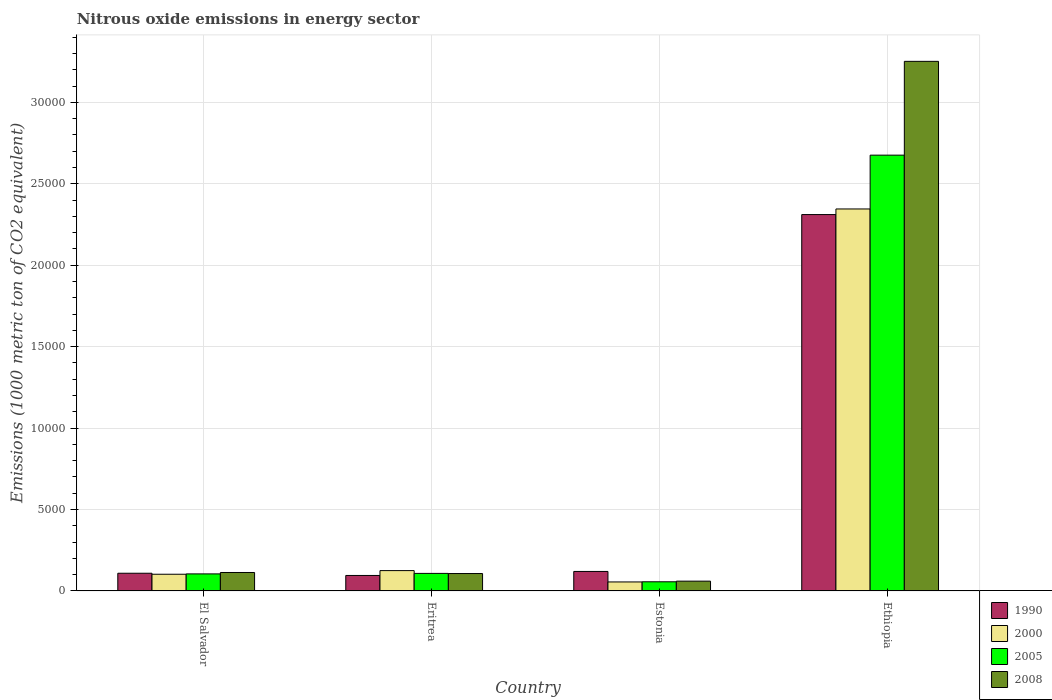How many groups of bars are there?
Make the answer very short. 4. How many bars are there on the 3rd tick from the left?
Give a very brief answer. 4. What is the label of the 3rd group of bars from the left?
Offer a terse response. Estonia. What is the amount of nitrous oxide emitted in 2005 in Estonia?
Provide a succinct answer. 563.9. Across all countries, what is the maximum amount of nitrous oxide emitted in 1990?
Make the answer very short. 2.31e+04. Across all countries, what is the minimum amount of nitrous oxide emitted in 2000?
Provide a short and direct response. 554.4. In which country was the amount of nitrous oxide emitted in 2000 maximum?
Ensure brevity in your answer.  Ethiopia. In which country was the amount of nitrous oxide emitted in 1990 minimum?
Make the answer very short. Eritrea. What is the total amount of nitrous oxide emitted in 1990 in the graph?
Offer a very short reply. 2.64e+04. What is the difference between the amount of nitrous oxide emitted in 2005 in Eritrea and that in Estonia?
Your answer should be very brief. 515.4. What is the difference between the amount of nitrous oxide emitted in 1990 in Eritrea and the amount of nitrous oxide emitted in 2008 in Estonia?
Your response must be concise. 349. What is the average amount of nitrous oxide emitted in 2005 per country?
Your answer should be very brief. 7363.52. What is the difference between the amount of nitrous oxide emitted of/in 2000 and amount of nitrous oxide emitted of/in 1990 in El Salvador?
Give a very brief answer. -60.8. What is the ratio of the amount of nitrous oxide emitted in 1990 in Eritrea to that in Ethiopia?
Provide a short and direct response. 0.04. What is the difference between the highest and the second highest amount of nitrous oxide emitted in 2005?
Ensure brevity in your answer.  2.57e+04. What is the difference between the highest and the lowest amount of nitrous oxide emitted in 2008?
Your answer should be very brief. 3.19e+04. Is it the case that in every country, the sum of the amount of nitrous oxide emitted in 2000 and amount of nitrous oxide emitted in 2005 is greater than the sum of amount of nitrous oxide emitted in 2008 and amount of nitrous oxide emitted in 1990?
Ensure brevity in your answer.  No. What does the 2nd bar from the left in Ethiopia represents?
Provide a short and direct response. 2000. What does the 4th bar from the right in Estonia represents?
Keep it short and to the point. 1990. Is it the case that in every country, the sum of the amount of nitrous oxide emitted in 2000 and amount of nitrous oxide emitted in 2008 is greater than the amount of nitrous oxide emitted in 1990?
Keep it short and to the point. No. How many bars are there?
Your answer should be compact. 16. How many countries are there in the graph?
Your answer should be compact. 4. Does the graph contain any zero values?
Your answer should be very brief. No. Does the graph contain grids?
Keep it short and to the point. Yes. How many legend labels are there?
Make the answer very short. 4. How are the legend labels stacked?
Provide a short and direct response. Vertical. What is the title of the graph?
Your answer should be compact. Nitrous oxide emissions in energy sector. What is the label or title of the Y-axis?
Give a very brief answer. Emissions (1000 metric ton of CO2 equivalent). What is the Emissions (1000 metric ton of CO2 equivalent) of 1990 in El Salvador?
Make the answer very short. 1088.8. What is the Emissions (1000 metric ton of CO2 equivalent) of 2000 in El Salvador?
Your answer should be very brief. 1028. What is the Emissions (1000 metric ton of CO2 equivalent) of 2005 in El Salvador?
Provide a short and direct response. 1049.1. What is the Emissions (1000 metric ton of CO2 equivalent) of 2008 in El Salvador?
Your answer should be compact. 1135. What is the Emissions (1000 metric ton of CO2 equivalent) of 1990 in Eritrea?
Your response must be concise. 953. What is the Emissions (1000 metric ton of CO2 equivalent) in 2000 in Eritrea?
Your answer should be very brief. 1251.3. What is the Emissions (1000 metric ton of CO2 equivalent) in 2005 in Eritrea?
Your answer should be compact. 1079.3. What is the Emissions (1000 metric ton of CO2 equivalent) of 2008 in Eritrea?
Provide a short and direct response. 1070.9. What is the Emissions (1000 metric ton of CO2 equivalent) in 1990 in Estonia?
Your answer should be very brief. 1199.7. What is the Emissions (1000 metric ton of CO2 equivalent) of 2000 in Estonia?
Offer a terse response. 554.4. What is the Emissions (1000 metric ton of CO2 equivalent) of 2005 in Estonia?
Offer a very short reply. 563.9. What is the Emissions (1000 metric ton of CO2 equivalent) of 2008 in Estonia?
Ensure brevity in your answer.  604. What is the Emissions (1000 metric ton of CO2 equivalent) of 1990 in Ethiopia?
Provide a succinct answer. 2.31e+04. What is the Emissions (1000 metric ton of CO2 equivalent) of 2000 in Ethiopia?
Ensure brevity in your answer.  2.35e+04. What is the Emissions (1000 metric ton of CO2 equivalent) of 2005 in Ethiopia?
Provide a short and direct response. 2.68e+04. What is the Emissions (1000 metric ton of CO2 equivalent) of 2008 in Ethiopia?
Provide a succinct answer. 3.25e+04. Across all countries, what is the maximum Emissions (1000 metric ton of CO2 equivalent) in 1990?
Give a very brief answer. 2.31e+04. Across all countries, what is the maximum Emissions (1000 metric ton of CO2 equivalent) in 2000?
Your response must be concise. 2.35e+04. Across all countries, what is the maximum Emissions (1000 metric ton of CO2 equivalent) in 2005?
Ensure brevity in your answer.  2.68e+04. Across all countries, what is the maximum Emissions (1000 metric ton of CO2 equivalent) in 2008?
Your answer should be compact. 3.25e+04. Across all countries, what is the minimum Emissions (1000 metric ton of CO2 equivalent) of 1990?
Make the answer very short. 953. Across all countries, what is the minimum Emissions (1000 metric ton of CO2 equivalent) of 2000?
Ensure brevity in your answer.  554.4. Across all countries, what is the minimum Emissions (1000 metric ton of CO2 equivalent) in 2005?
Give a very brief answer. 563.9. Across all countries, what is the minimum Emissions (1000 metric ton of CO2 equivalent) of 2008?
Your response must be concise. 604. What is the total Emissions (1000 metric ton of CO2 equivalent) in 1990 in the graph?
Your response must be concise. 2.64e+04. What is the total Emissions (1000 metric ton of CO2 equivalent) in 2000 in the graph?
Ensure brevity in your answer.  2.63e+04. What is the total Emissions (1000 metric ton of CO2 equivalent) in 2005 in the graph?
Give a very brief answer. 2.95e+04. What is the total Emissions (1000 metric ton of CO2 equivalent) of 2008 in the graph?
Ensure brevity in your answer.  3.53e+04. What is the difference between the Emissions (1000 metric ton of CO2 equivalent) of 1990 in El Salvador and that in Eritrea?
Offer a terse response. 135.8. What is the difference between the Emissions (1000 metric ton of CO2 equivalent) in 2000 in El Salvador and that in Eritrea?
Offer a very short reply. -223.3. What is the difference between the Emissions (1000 metric ton of CO2 equivalent) in 2005 in El Salvador and that in Eritrea?
Your answer should be very brief. -30.2. What is the difference between the Emissions (1000 metric ton of CO2 equivalent) in 2008 in El Salvador and that in Eritrea?
Give a very brief answer. 64.1. What is the difference between the Emissions (1000 metric ton of CO2 equivalent) of 1990 in El Salvador and that in Estonia?
Your answer should be compact. -110.9. What is the difference between the Emissions (1000 metric ton of CO2 equivalent) in 2000 in El Salvador and that in Estonia?
Ensure brevity in your answer.  473.6. What is the difference between the Emissions (1000 metric ton of CO2 equivalent) in 2005 in El Salvador and that in Estonia?
Keep it short and to the point. 485.2. What is the difference between the Emissions (1000 metric ton of CO2 equivalent) in 2008 in El Salvador and that in Estonia?
Keep it short and to the point. 531. What is the difference between the Emissions (1000 metric ton of CO2 equivalent) of 1990 in El Salvador and that in Ethiopia?
Your response must be concise. -2.20e+04. What is the difference between the Emissions (1000 metric ton of CO2 equivalent) in 2000 in El Salvador and that in Ethiopia?
Keep it short and to the point. -2.24e+04. What is the difference between the Emissions (1000 metric ton of CO2 equivalent) of 2005 in El Salvador and that in Ethiopia?
Make the answer very short. -2.57e+04. What is the difference between the Emissions (1000 metric ton of CO2 equivalent) in 2008 in El Salvador and that in Ethiopia?
Your answer should be very brief. -3.14e+04. What is the difference between the Emissions (1000 metric ton of CO2 equivalent) in 1990 in Eritrea and that in Estonia?
Ensure brevity in your answer.  -246.7. What is the difference between the Emissions (1000 metric ton of CO2 equivalent) of 2000 in Eritrea and that in Estonia?
Your response must be concise. 696.9. What is the difference between the Emissions (1000 metric ton of CO2 equivalent) in 2005 in Eritrea and that in Estonia?
Provide a short and direct response. 515.4. What is the difference between the Emissions (1000 metric ton of CO2 equivalent) of 2008 in Eritrea and that in Estonia?
Offer a terse response. 466.9. What is the difference between the Emissions (1000 metric ton of CO2 equivalent) of 1990 in Eritrea and that in Ethiopia?
Keep it short and to the point. -2.22e+04. What is the difference between the Emissions (1000 metric ton of CO2 equivalent) in 2000 in Eritrea and that in Ethiopia?
Provide a succinct answer. -2.22e+04. What is the difference between the Emissions (1000 metric ton of CO2 equivalent) in 2005 in Eritrea and that in Ethiopia?
Ensure brevity in your answer.  -2.57e+04. What is the difference between the Emissions (1000 metric ton of CO2 equivalent) of 2008 in Eritrea and that in Ethiopia?
Your answer should be compact. -3.15e+04. What is the difference between the Emissions (1000 metric ton of CO2 equivalent) of 1990 in Estonia and that in Ethiopia?
Offer a very short reply. -2.19e+04. What is the difference between the Emissions (1000 metric ton of CO2 equivalent) in 2000 in Estonia and that in Ethiopia?
Make the answer very short. -2.29e+04. What is the difference between the Emissions (1000 metric ton of CO2 equivalent) in 2005 in Estonia and that in Ethiopia?
Ensure brevity in your answer.  -2.62e+04. What is the difference between the Emissions (1000 metric ton of CO2 equivalent) of 2008 in Estonia and that in Ethiopia?
Provide a succinct answer. -3.19e+04. What is the difference between the Emissions (1000 metric ton of CO2 equivalent) in 1990 in El Salvador and the Emissions (1000 metric ton of CO2 equivalent) in 2000 in Eritrea?
Give a very brief answer. -162.5. What is the difference between the Emissions (1000 metric ton of CO2 equivalent) of 2000 in El Salvador and the Emissions (1000 metric ton of CO2 equivalent) of 2005 in Eritrea?
Offer a very short reply. -51.3. What is the difference between the Emissions (1000 metric ton of CO2 equivalent) of 2000 in El Salvador and the Emissions (1000 metric ton of CO2 equivalent) of 2008 in Eritrea?
Give a very brief answer. -42.9. What is the difference between the Emissions (1000 metric ton of CO2 equivalent) of 2005 in El Salvador and the Emissions (1000 metric ton of CO2 equivalent) of 2008 in Eritrea?
Keep it short and to the point. -21.8. What is the difference between the Emissions (1000 metric ton of CO2 equivalent) of 1990 in El Salvador and the Emissions (1000 metric ton of CO2 equivalent) of 2000 in Estonia?
Give a very brief answer. 534.4. What is the difference between the Emissions (1000 metric ton of CO2 equivalent) of 1990 in El Salvador and the Emissions (1000 metric ton of CO2 equivalent) of 2005 in Estonia?
Your answer should be very brief. 524.9. What is the difference between the Emissions (1000 metric ton of CO2 equivalent) of 1990 in El Salvador and the Emissions (1000 metric ton of CO2 equivalent) of 2008 in Estonia?
Give a very brief answer. 484.8. What is the difference between the Emissions (1000 metric ton of CO2 equivalent) of 2000 in El Salvador and the Emissions (1000 metric ton of CO2 equivalent) of 2005 in Estonia?
Provide a short and direct response. 464.1. What is the difference between the Emissions (1000 metric ton of CO2 equivalent) in 2000 in El Salvador and the Emissions (1000 metric ton of CO2 equivalent) in 2008 in Estonia?
Make the answer very short. 424. What is the difference between the Emissions (1000 metric ton of CO2 equivalent) of 2005 in El Salvador and the Emissions (1000 metric ton of CO2 equivalent) of 2008 in Estonia?
Offer a terse response. 445.1. What is the difference between the Emissions (1000 metric ton of CO2 equivalent) of 1990 in El Salvador and the Emissions (1000 metric ton of CO2 equivalent) of 2000 in Ethiopia?
Provide a short and direct response. -2.24e+04. What is the difference between the Emissions (1000 metric ton of CO2 equivalent) of 1990 in El Salvador and the Emissions (1000 metric ton of CO2 equivalent) of 2005 in Ethiopia?
Ensure brevity in your answer.  -2.57e+04. What is the difference between the Emissions (1000 metric ton of CO2 equivalent) in 1990 in El Salvador and the Emissions (1000 metric ton of CO2 equivalent) in 2008 in Ethiopia?
Offer a very short reply. -3.14e+04. What is the difference between the Emissions (1000 metric ton of CO2 equivalent) of 2000 in El Salvador and the Emissions (1000 metric ton of CO2 equivalent) of 2005 in Ethiopia?
Keep it short and to the point. -2.57e+04. What is the difference between the Emissions (1000 metric ton of CO2 equivalent) of 2000 in El Salvador and the Emissions (1000 metric ton of CO2 equivalent) of 2008 in Ethiopia?
Keep it short and to the point. -3.15e+04. What is the difference between the Emissions (1000 metric ton of CO2 equivalent) of 2005 in El Salvador and the Emissions (1000 metric ton of CO2 equivalent) of 2008 in Ethiopia?
Provide a short and direct response. -3.15e+04. What is the difference between the Emissions (1000 metric ton of CO2 equivalent) of 1990 in Eritrea and the Emissions (1000 metric ton of CO2 equivalent) of 2000 in Estonia?
Your answer should be compact. 398.6. What is the difference between the Emissions (1000 metric ton of CO2 equivalent) in 1990 in Eritrea and the Emissions (1000 metric ton of CO2 equivalent) in 2005 in Estonia?
Keep it short and to the point. 389.1. What is the difference between the Emissions (1000 metric ton of CO2 equivalent) of 1990 in Eritrea and the Emissions (1000 metric ton of CO2 equivalent) of 2008 in Estonia?
Give a very brief answer. 349. What is the difference between the Emissions (1000 metric ton of CO2 equivalent) of 2000 in Eritrea and the Emissions (1000 metric ton of CO2 equivalent) of 2005 in Estonia?
Keep it short and to the point. 687.4. What is the difference between the Emissions (1000 metric ton of CO2 equivalent) in 2000 in Eritrea and the Emissions (1000 metric ton of CO2 equivalent) in 2008 in Estonia?
Offer a very short reply. 647.3. What is the difference between the Emissions (1000 metric ton of CO2 equivalent) in 2005 in Eritrea and the Emissions (1000 metric ton of CO2 equivalent) in 2008 in Estonia?
Give a very brief answer. 475.3. What is the difference between the Emissions (1000 metric ton of CO2 equivalent) in 1990 in Eritrea and the Emissions (1000 metric ton of CO2 equivalent) in 2000 in Ethiopia?
Your answer should be very brief. -2.25e+04. What is the difference between the Emissions (1000 metric ton of CO2 equivalent) of 1990 in Eritrea and the Emissions (1000 metric ton of CO2 equivalent) of 2005 in Ethiopia?
Ensure brevity in your answer.  -2.58e+04. What is the difference between the Emissions (1000 metric ton of CO2 equivalent) of 1990 in Eritrea and the Emissions (1000 metric ton of CO2 equivalent) of 2008 in Ethiopia?
Your answer should be compact. -3.16e+04. What is the difference between the Emissions (1000 metric ton of CO2 equivalent) in 2000 in Eritrea and the Emissions (1000 metric ton of CO2 equivalent) in 2005 in Ethiopia?
Keep it short and to the point. -2.55e+04. What is the difference between the Emissions (1000 metric ton of CO2 equivalent) in 2000 in Eritrea and the Emissions (1000 metric ton of CO2 equivalent) in 2008 in Ethiopia?
Provide a succinct answer. -3.13e+04. What is the difference between the Emissions (1000 metric ton of CO2 equivalent) of 2005 in Eritrea and the Emissions (1000 metric ton of CO2 equivalent) of 2008 in Ethiopia?
Ensure brevity in your answer.  -3.14e+04. What is the difference between the Emissions (1000 metric ton of CO2 equivalent) of 1990 in Estonia and the Emissions (1000 metric ton of CO2 equivalent) of 2000 in Ethiopia?
Give a very brief answer. -2.23e+04. What is the difference between the Emissions (1000 metric ton of CO2 equivalent) in 1990 in Estonia and the Emissions (1000 metric ton of CO2 equivalent) in 2005 in Ethiopia?
Your answer should be very brief. -2.56e+04. What is the difference between the Emissions (1000 metric ton of CO2 equivalent) in 1990 in Estonia and the Emissions (1000 metric ton of CO2 equivalent) in 2008 in Ethiopia?
Your answer should be compact. -3.13e+04. What is the difference between the Emissions (1000 metric ton of CO2 equivalent) in 2000 in Estonia and the Emissions (1000 metric ton of CO2 equivalent) in 2005 in Ethiopia?
Your answer should be very brief. -2.62e+04. What is the difference between the Emissions (1000 metric ton of CO2 equivalent) in 2000 in Estonia and the Emissions (1000 metric ton of CO2 equivalent) in 2008 in Ethiopia?
Your answer should be compact. -3.20e+04. What is the difference between the Emissions (1000 metric ton of CO2 equivalent) of 2005 in Estonia and the Emissions (1000 metric ton of CO2 equivalent) of 2008 in Ethiopia?
Give a very brief answer. -3.20e+04. What is the average Emissions (1000 metric ton of CO2 equivalent) of 1990 per country?
Give a very brief answer. 6588.68. What is the average Emissions (1000 metric ton of CO2 equivalent) in 2000 per country?
Your answer should be compact. 6572.85. What is the average Emissions (1000 metric ton of CO2 equivalent) of 2005 per country?
Your answer should be very brief. 7363.52. What is the average Emissions (1000 metric ton of CO2 equivalent) of 2008 per country?
Your response must be concise. 8832.75. What is the difference between the Emissions (1000 metric ton of CO2 equivalent) in 1990 and Emissions (1000 metric ton of CO2 equivalent) in 2000 in El Salvador?
Keep it short and to the point. 60.8. What is the difference between the Emissions (1000 metric ton of CO2 equivalent) of 1990 and Emissions (1000 metric ton of CO2 equivalent) of 2005 in El Salvador?
Your response must be concise. 39.7. What is the difference between the Emissions (1000 metric ton of CO2 equivalent) in 1990 and Emissions (1000 metric ton of CO2 equivalent) in 2008 in El Salvador?
Provide a succinct answer. -46.2. What is the difference between the Emissions (1000 metric ton of CO2 equivalent) in 2000 and Emissions (1000 metric ton of CO2 equivalent) in 2005 in El Salvador?
Give a very brief answer. -21.1. What is the difference between the Emissions (1000 metric ton of CO2 equivalent) of 2000 and Emissions (1000 metric ton of CO2 equivalent) of 2008 in El Salvador?
Provide a succinct answer. -107. What is the difference between the Emissions (1000 metric ton of CO2 equivalent) of 2005 and Emissions (1000 metric ton of CO2 equivalent) of 2008 in El Salvador?
Your answer should be very brief. -85.9. What is the difference between the Emissions (1000 metric ton of CO2 equivalent) of 1990 and Emissions (1000 metric ton of CO2 equivalent) of 2000 in Eritrea?
Make the answer very short. -298.3. What is the difference between the Emissions (1000 metric ton of CO2 equivalent) in 1990 and Emissions (1000 metric ton of CO2 equivalent) in 2005 in Eritrea?
Provide a succinct answer. -126.3. What is the difference between the Emissions (1000 metric ton of CO2 equivalent) in 1990 and Emissions (1000 metric ton of CO2 equivalent) in 2008 in Eritrea?
Give a very brief answer. -117.9. What is the difference between the Emissions (1000 metric ton of CO2 equivalent) in 2000 and Emissions (1000 metric ton of CO2 equivalent) in 2005 in Eritrea?
Offer a terse response. 172. What is the difference between the Emissions (1000 metric ton of CO2 equivalent) in 2000 and Emissions (1000 metric ton of CO2 equivalent) in 2008 in Eritrea?
Offer a terse response. 180.4. What is the difference between the Emissions (1000 metric ton of CO2 equivalent) of 1990 and Emissions (1000 metric ton of CO2 equivalent) of 2000 in Estonia?
Your response must be concise. 645.3. What is the difference between the Emissions (1000 metric ton of CO2 equivalent) in 1990 and Emissions (1000 metric ton of CO2 equivalent) in 2005 in Estonia?
Offer a terse response. 635.8. What is the difference between the Emissions (1000 metric ton of CO2 equivalent) of 1990 and Emissions (1000 metric ton of CO2 equivalent) of 2008 in Estonia?
Provide a short and direct response. 595.7. What is the difference between the Emissions (1000 metric ton of CO2 equivalent) of 2000 and Emissions (1000 metric ton of CO2 equivalent) of 2005 in Estonia?
Your answer should be compact. -9.5. What is the difference between the Emissions (1000 metric ton of CO2 equivalent) of 2000 and Emissions (1000 metric ton of CO2 equivalent) of 2008 in Estonia?
Offer a terse response. -49.6. What is the difference between the Emissions (1000 metric ton of CO2 equivalent) of 2005 and Emissions (1000 metric ton of CO2 equivalent) of 2008 in Estonia?
Your response must be concise. -40.1. What is the difference between the Emissions (1000 metric ton of CO2 equivalent) in 1990 and Emissions (1000 metric ton of CO2 equivalent) in 2000 in Ethiopia?
Your response must be concise. -344.5. What is the difference between the Emissions (1000 metric ton of CO2 equivalent) of 1990 and Emissions (1000 metric ton of CO2 equivalent) of 2005 in Ethiopia?
Keep it short and to the point. -3648.6. What is the difference between the Emissions (1000 metric ton of CO2 equivalent) of 1990 and Emissions (1000 metric ton of CO2 equivalent) of 2008 in Ethiopia?
Your response must be concise. -9407.9. What is the difference between the Emissions (1000 metric ton of CO2 equivalent) of 2000 and Emissions (1000 metric ton of CO2 equivalent) of 2005 in Ethiopia?
Keep it short and to the point. -3304.1. What is the difference between the Emissions (1000 metric ton of CO2 equivalent) in 2000 and Emissions (1000 metric ton of CO2 equivalent) in 2008 in Ethiopia?
Your response must be concise. -9063.4. What is the difference between the Emissions (1000 metric ton of CO2 equivalent) of 2005 and Emissions (1000 metric ton of CO2 equivalent) of 2008 in Ethiopia?
Your answer should be very brief. -5759.3. What is the ratio of the Emissions (1000 metric ton of CO2 equivalent) of 1990 in El Salvador to that in Eritrea?
Ensure brevity in your answer.  1.14. What is the ratio of the Emissions (1000 metric ton of CO2 equivalent) in 2000 in El Salvador to that in Eritrea?
Make the answer very short. 0.82. What is the ratio of the Emissions (1000 metric ton of CO2 equivalent) of 2008 in El Salvador to that in Eritrea?
Provide a short and direct response. 1.06. What is the ratio of the Emissions (1000 metric ton of CO2 equivalent) of 1990 in El Salvador to that in Estonia?
Your response must be concise. 0.91. What is the ratio of the Emissions (1000 metric ton of CO2 equivalent) in 2000 in El Salvador to that in Estonia?
Offer a very short reply. 1.85. What is the ratio of the Emissions (1000 metric ton of CO2 equivalent) of 2005 in El Salvador to that in Estonia?
Give a very brief answer. 1.86. What is the ratio of the Emissions (1000 metric ton of CO2 equivalent) of 2008 in El Salvador to that in Estonia?
Your response must be concise. 1.88. What is the ratio of the Emissions (1000 metric ton of CO2 equivalent) of 1990 in El Salvador to that in Ethiopia?
Ensure brevity in your answer.  0.05. What is the ratio of the Emissions (1000 metric ton of CO2 equivalent) in 2000 in El Salvador to that in Ethiopia?
Your answer should be compact. 0.04. What is the ratio of the Emissions (1000 metric ton of CO2 equivalent) in 2005 in El Salvador to that in Ethiopia?
Make the answer very short. 0.04. What is the ratio of the Emissions (1000 metric ton of CO2 equivalent) in 2008 in El Salvador to that in Ethiopia?
Your answer should be compact. 0.03. What is the ratio of the Emissions (1000 metric ton of CO2 equivalent) in 1990 in Eritrea to that in Estonia?
Provide a succinct answer. 0.79. What is the ratio of the Emissions (1000 metric ton of CO2 equivalent) in 2000 in Eritrea to that in Estonia?
Make the answer very short. 2.26. What is the ratio of the Emissions (1000 metric ton of CO2 equivalent) of 2005 in Eritrea to that in Estonia?
Offer a terse response. 1.91. What is the ratio of the Emissions (1000 metric ton of CO2 equivalent) in 2008 in Eritrea to that in Estonia?
Offer a very short reply. 1.77. What is the ratio of the Emissions (1000 metric ton of CO2 equivalent) in 1990 in Eritrea to that in Ethiopia?
Give a very brief answer. 0.04. What is the ratio of the Emissions (1000 metric ton of CO2 equivalent) of 2000 in Eritrea to that in Ethiopia?
Provide a succinct answer. 0.05. What is the ratio of the Emissions (1000 metric ton of CO2 equivalent) of 2005 in Eritrea to that in Ethiopia?
Offer a very short reply. 0.04. What is the ratio of the Emissions (1000 metric ton of CO2 equivalent) of 2008 in Eritrea to that in Ethiopia?
Ensure brevity in your answer.  0.03. What is the ratio of the Emissions (1000 metric ton of CO2 equivalent) of 1990 in Estonia to that in Ethiopia?
Keep it short and to the point. 0.05. What is the ratio of the Emissions (1000 metric ton of CO2 equivalent) of 2000 in Estonia to that in Ethiopia?
Ensure brevity in your answer.  0.02. What is the ratio of the Emissions (1000 metric ton of CO2 equivalent) in 2005 in Estonia to that in Ethiopia?
Provide a short and direct response. 0.02. What is the ratio of the Emissions (1000 metric ton of CO2 equivalent) of 2008 in Estonia to that in Ethiopia?
Ensure brevity in your answer.  0.02. What is the difference between the highest and the second highest Emissions (1000 metric ton of CO2 equivalent) of 1990?
Make the answer very short. 2.19e+04. What is the difference between the highest and the second highest Emissions (1000 metric ton of CO2 equivalent) of 2000?
Your answer should be very brief. 2.22e+04. What is the difference between the highest and the second highest Emissions (1000 metric ton of CO2 equivalent) of 2005?
Provide a short and direct response. 2.57e+04. What is the difference between the highest and the second highest Emissions (1000 metric ton of CO2 equivalent) of 2008?
Ensure brevity in your answer.  3.14e+04. What is the difference between the highest and the lowest Emissions (1000 metric ton of CO2 equivalent) of 1990?
Offer a very short reply. 2.22e+04. What is the difference between the highest and the lowest Emissions (1000 metric ton of CO2 equivalent) of 2000?
Ensure brevity in your answer.  2.29e+04. What is the difference between the highest and the lowest Emissions (1000 metric ton of CO2 equivalent) in 2005?
Provide a succinct answer. 2.62e+04. What is the difference between the highest and the lowest Emissions (1000 metric ton of CO2 equivalent) in 2008?
Give a very brief answer. 3.19e+04. 